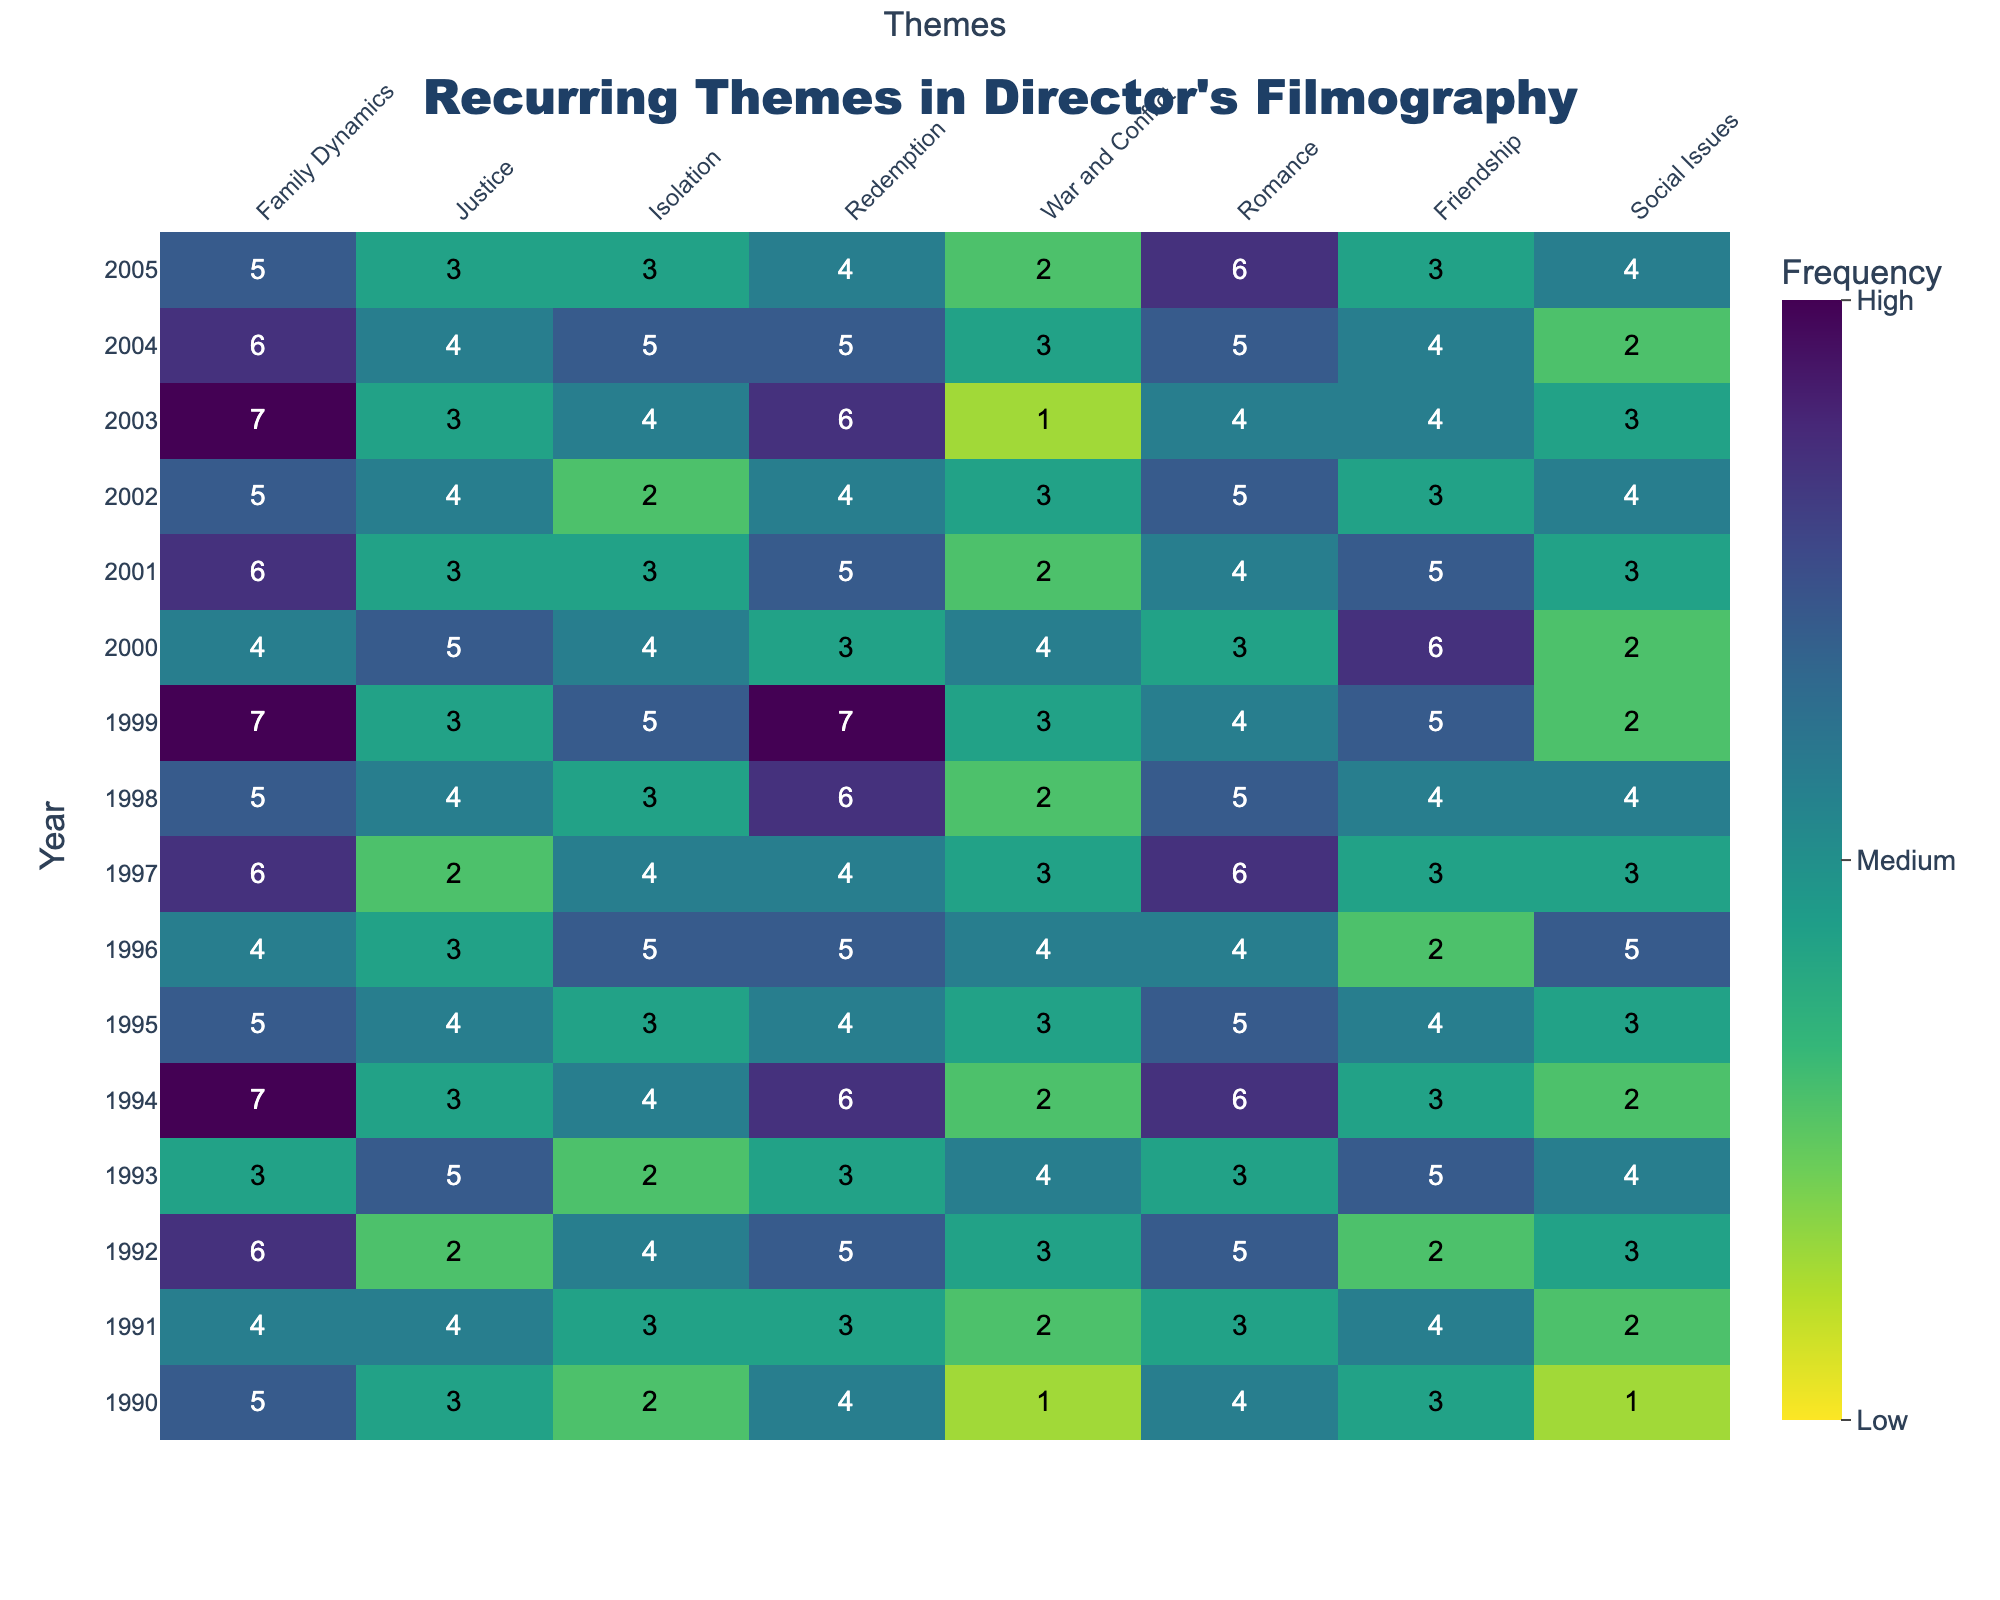What is the title of the figure? The title of the figure is displayed at the top of the plot.
Answer: Recurring Themes in Director's Filmography Which theme had the highest frequency in the year 1999? By looking at the y-axis for the year 1999 and finding the cell with the highest value, we see that "Redemption" has the value 7.
Answer: Redemption How many times was the theme "War and Conflict" significant (frequency ≥ 4) throughout the years? Count all cells under "War and Conflict" where the value is greater than or equal to 4. The significant cells are: 1992, 1994, 1996, 2000, and 2004, making it 5.
Answer: 5 Between which years did "Family Dynamics" see the highest frequency and what was the value? Looking at "Family Dynamics" across the years, the highest value is 7, which appears in both 1994 and 1999.
Answer: 1994 and 1999; 7 What is the average frequency of the theme "Romance" over the years? Sum all values under "Romance" and divide by the number of years (15). The sum is 65, so 65/15 = 4.33.
Answer: 4.33 Which year had the most recurring theme frequencies combined, and what is the total frequency? Add up the frequency of all themes for each year. The year with the highest sum is 1999 with a total frequency of 36.
Answer: 1999; 36 Which theme had the least frequency in 1993, and what was the value? Look at the values for all themes in 1993 and find the minimum. The smallest value is 2 for "Family Dynamics" and "Isolation".
Answer: Family Dynamics and Isolation; 2 How did the frequency of "Social Issues" change from 2000 to 2004? Compare the frequencies in 2000 (2) and 2004 (2), noting any changes. The value remained constant at 2.
Answer: No change In which year did "Friendship" see a peak frequency, and what was the frequency? Find the highest value under "Friendship" across all years. The peak frequency of 6 appeared in 2000.
Answer: 2000; 6 Which themes showed a steady increase from 1991 to 1993, and by how much did they increase? Compare the frequencies for each theme from 1991 to 1993. "Redemption" increased from 2 to 4, and "Justice" increased from 3 to 5. Both themes increased by 2.
Answer: Redemption and Justice; increase by 2 